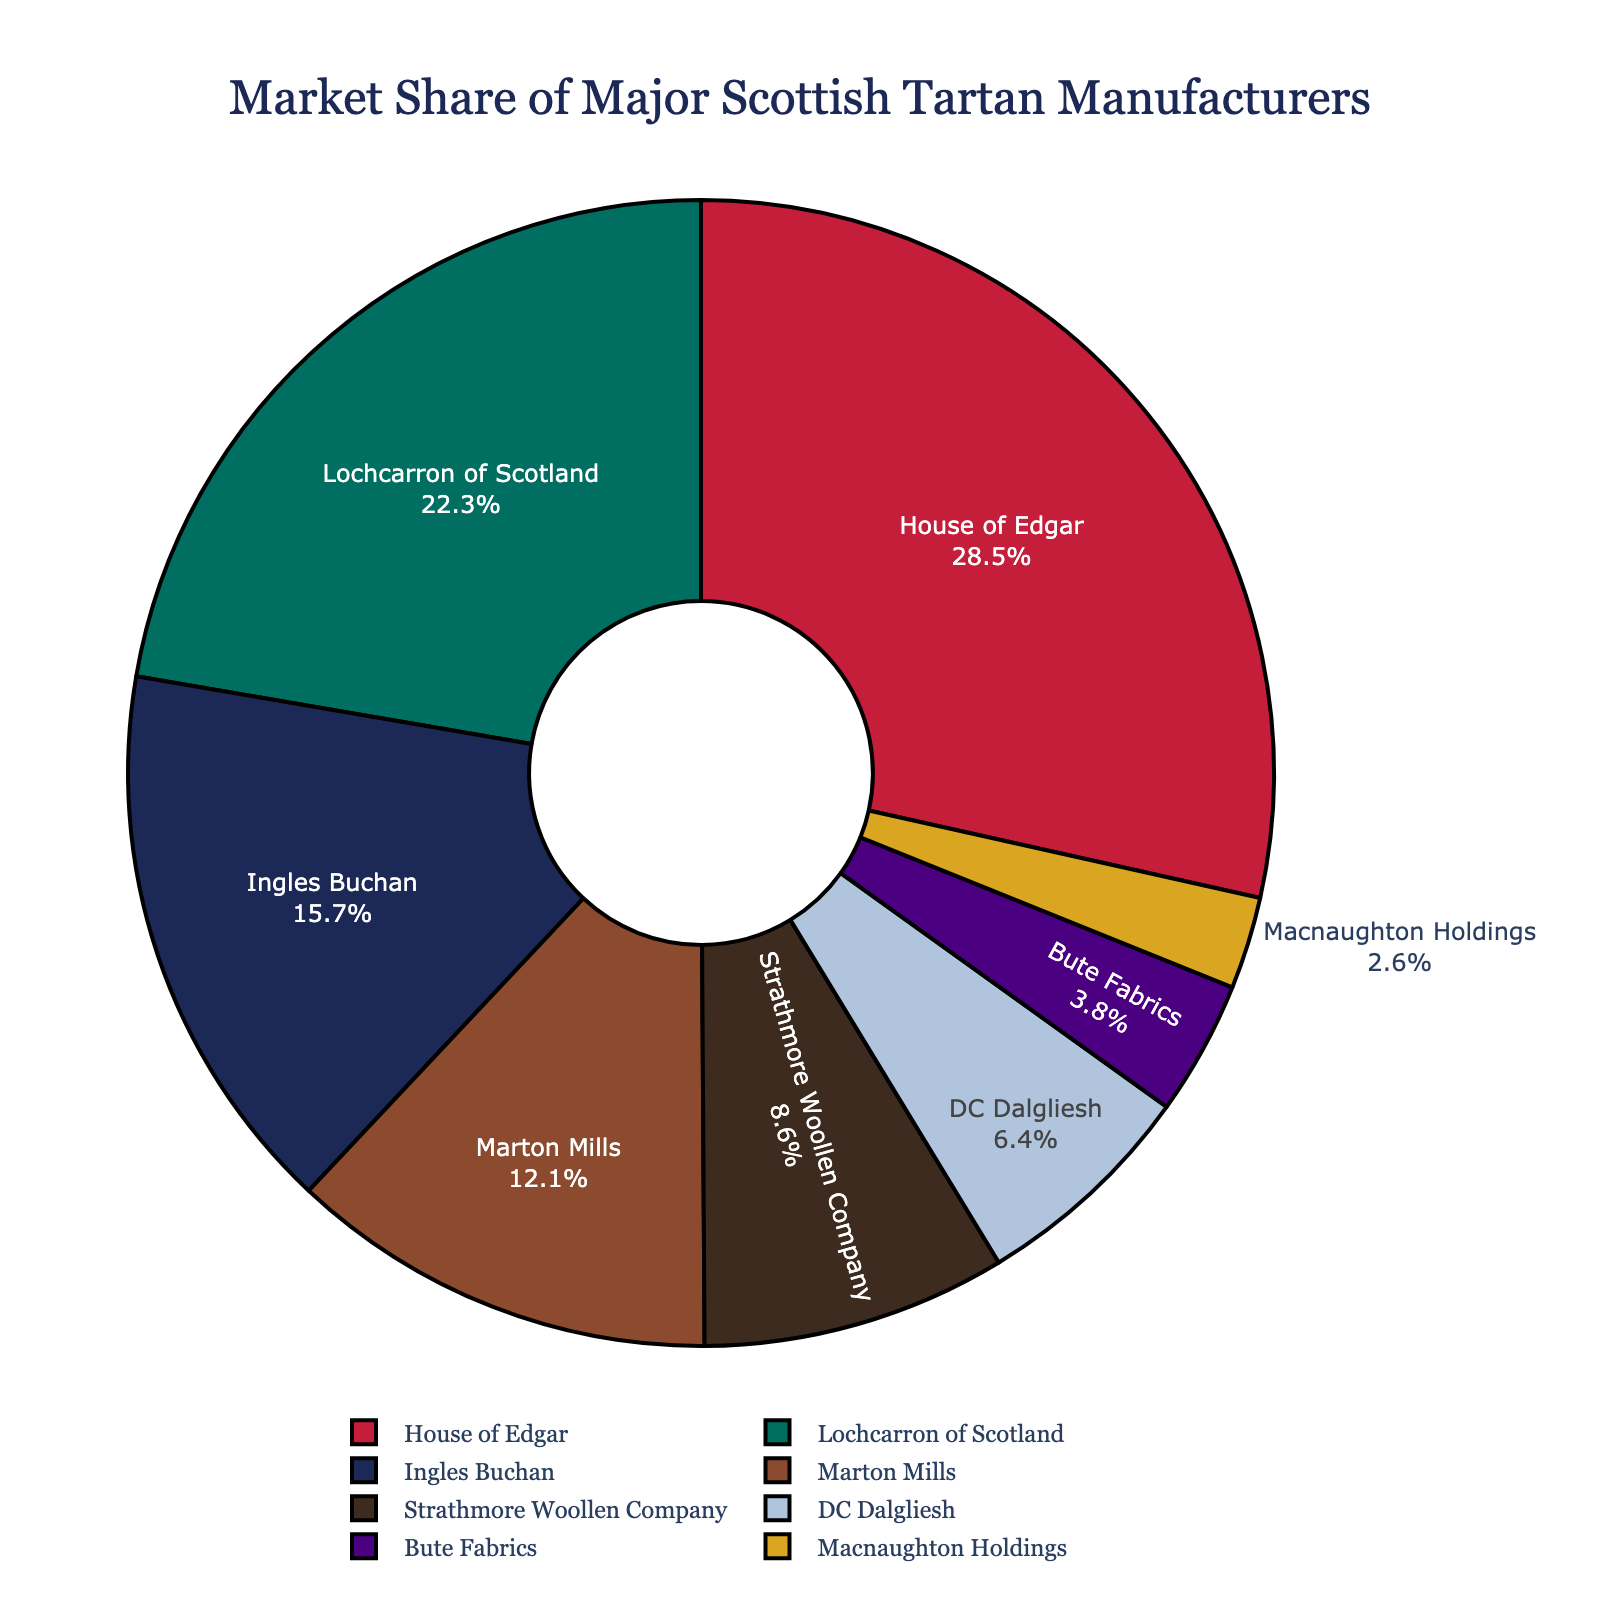What percentage of the market share do House of Edgar and Lochcarron of Scotland together hold? House of Edgar has a market share of 28.5% and Lochcarron of Scotland has a market share of 22.3%. To find their combined market share, add these two percentages: 28.5% + 22.3% = 50.8%.
Answer: 50.8% Which company has the smallest market share and what is it? The companies are listed with their market shares, and the smallest one is Macnaughton Holdings with 2.6%.
Answer: Macnaughton Holdings, 2.6% How much more market share does House of Edgar have compared to Ingles Buchan? House of Edgar has a market share of 28.5%, and Ingles Buchan has 15.7%. Subtract Ingles Buchan's market share from House of Edgar's to find the difference: 28.5% - 15.7% = 12.8%.
Answer: 12.8% What is the total market share of Marton Mills, Strathmore Woollen Company, and DC Dalgliesh combined? Marton Mills has a market share of 12.1%, Strathmore Woollen Company has 8.6%, and DC Dalgliesh has 6.4%. Add these together to get the total: 12.1% + 8.6% + 6.4% = 27.1%.
Answer: 27.1% Are there more companies with a market share greater than 10% or less than 10%? Count the companies with a market share greater than 10% (House of Edgar, Lochcarron of Scotland, Ingles Buchan, Marton Mills) which is 4, and those with less than 10% (Strathmore Woollen Company, DC Dalgliesh, Bute Fabrics, Macnaughton Holdings) which is also 4. They are equal in number.
Answer: Equal Which company's market share is closest to 10%? Looking at the companies, Strathmore Woollen Company has a market share of 8.6%, which is closest to 10%.
Answer: Strathmore Woollen Company Which company is represented by the green segment in the pie chart? By visual attribute, the green segment's color in the chart corresponds to the second largest market share. The company with the second largest market share is Lochcarron of Scotland.
Answer: Lochcarron of Scotland 